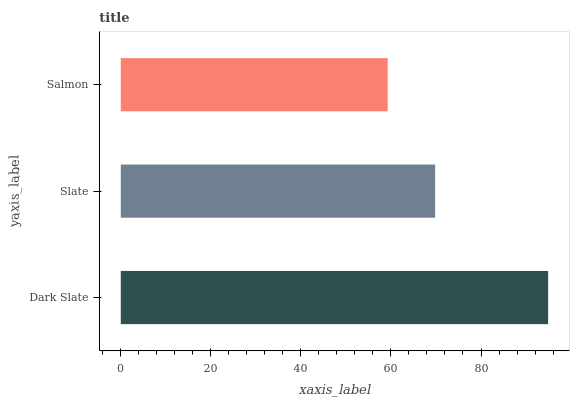Is Salmon the minimum?
Answer yes or no. Yes. Is Dark Slate the maximum?
Answer yes or no. Yes. Is Slate the minimum?
Answer yes or no. No. Is Slate the maximum?
Answer yes or no. No. Is Dark Slate greater than Slate?
Answer yes or no. Yes. Is Slate less than Dark Slate?
Answer yes or no. Yes. Is Slate greater than Dark Slate?
Answer yes or no. No. Is Dark Slate less than Slate?
Answer yes or no. No. Is Slate the high median?
Answer yes or no. Yes. Is Slate the low median?
Answer yes or no. Yes. Is Dark Slate the high median?
Answer yes or no. No. Is Dark Slate the low median?
Answer yes or no. No. 